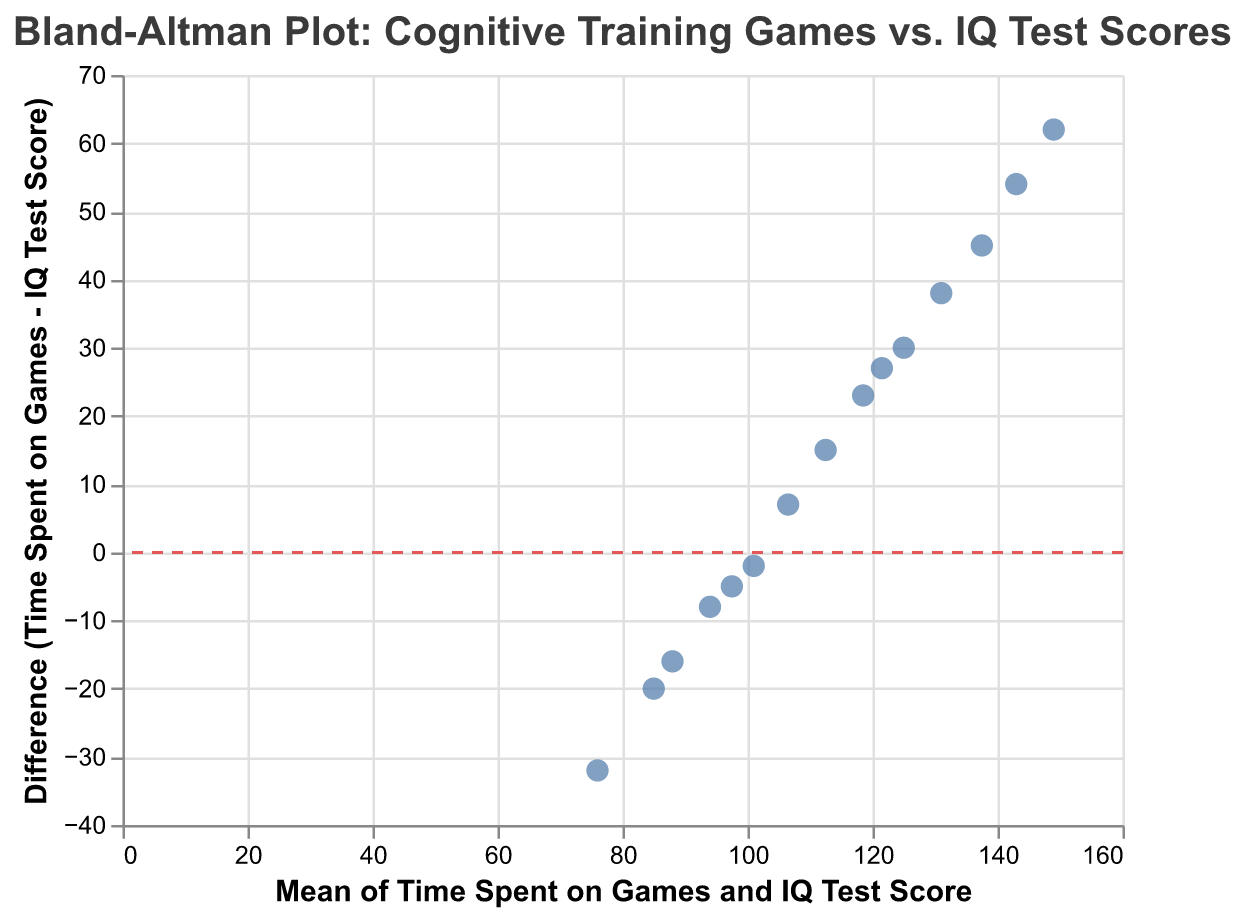What is the title of the plot? The title is located at the top of the plot and is typically in a larger and bolder font compared to other texts.
Answer: Bland-Altman Plot: Cognitive Training Games vs. IQ Test Scores How many data points are there in the plot? The plot shows individual data points as blue dots. By counting them, we find there are 15 data points.
Answer: 15 What does the x-axis represent in the plot? The x-axis title is "Mean of Time Spent on Games and IQ Test Score", as written at the bottom of the axis. This indicates the average value between the time spent on cognitive training games and the IQ test scores.
Answer: Mean of Time Spent on Games and IQ Test Score What is the range of values on the y-axis? The y-axis title is "Difference (Time Spent on Games - IQ Test Score)". By looking at the axis labels, we see it ranges from approximately -15 to 65.
Answer: -15 to 65 Which data point has the highest mean value on the x-axis? The data point with the highest mean value will be the rightmost point on the x-axis. This point represents the average between 180 and 118 which is 149.
Answer: 149 What is the mean value and difference for the lowest point on the y-axis? The lowest point on the y-axis has the smallest value for the difference and is identified visually. This point is for the pair 60 and 92, with a difference of -32 and a mean of 76.
Answer: Mean: 76, Difference: -32 Which data point has the largest positive difference? The largest positive difference is identified by finding the topmost data point on the y-axis. This point is for the pair 180 and 118, with a difference of 62.
Answer: Difference: 62 Identify the data point where the time spent on games is equal to the IQ test score. This requires finding the data point where the difference (y-axis) is zero. No data point has a 0 difference directly, so this scenario does not occur in the plot.
Answer: None What is the relationship between the mean and the difference values? To determine if there's a trend, one might notice visually that differences seem to increase with the mean values. This indicates a positive correlation between mean values and differences.
Answer: Positive correlation 